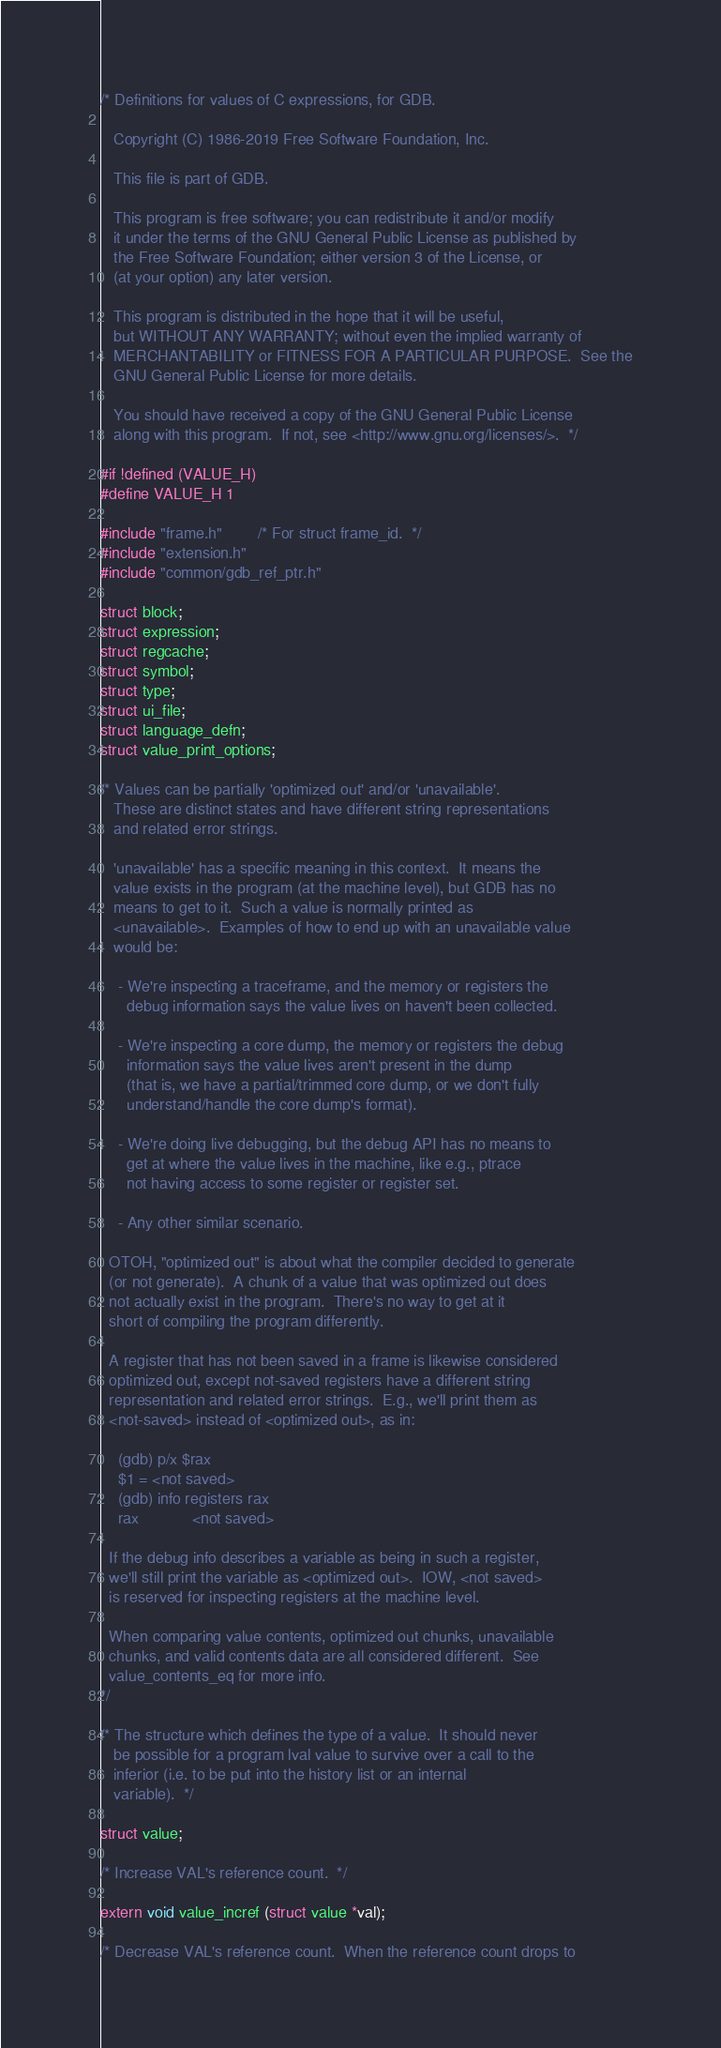Convert code to text. <code><loc_0><loc_0><loc_500><loc_500><_C_>/* Definitions for values of C expressions, for GDB.

   Copyright (C) 1986-2019 Free Software Foundation, Inc.

   This file is part of GDB.

   This program is free software; you can redistribute it and/or modify
   it under the terms of the GNU General Public License as published by
   the Free Software Foundation; either version 3 of the License, or
   (at your option) any later version.

   This program is distributed in the hope that it will be useful,
   but WITHOUT ANY WARRANTY; without even the implied warranty of
   MERCHANTABILITY or FITNESS FOR A PARTICULAR PURPOSE.  See the
   GNU General Public License for more details.

   You should have received a copy of the GNU General Public License
   along with this program.  If not, see <http://www.gnu.org/licenses/>.  */

#if !defined (VALUE_H)
#define VALUE_H 1

#include "frame.h"		/* For struct frame_id.  */
#include "extension.h"
#include "common/gdb_ref_ptr.h"

struct block;
struct expression;
struct regcache;
struct symbol;
struct type;
struct ui_file;
struct language_defn;
struct value_print_options;

/* Values can be partially 'optimized out' and/or 'unavailable'.
   These are distinct states and have different string representations
   and related error strings.

   'unavailable' has a specific meaning in this context.  It means the
   value exists in the program (at the machine level), but GDB has no
   means to get to it.  Such a value is normally printed as
   <unavailable>.  Examples of how to end up with an unavailable value
   would be:

    - We're inspecting a traceframe, and the memory or registers the
      debug information says the value lives on haven't been collected.

    - We're inspecting a core dump, the memory or registers the debug
      information says the value lives aren't present in the dump
      (that is, we have a partial/trimmed core dump, or we don't fully
      understand/handle the core dump's format).

    - We're doing live debugging, but the debug API has no means to
      get at where the value lives in the machine, like e.g., ptrace
      not having access to some register or register set.

    - Any other similar scenario.

  OTOH, "optimized out" is about what the compiler decided to generate
  (or not generate).  A chunk of a value that was optimized out does
  not actually exist in the program.  There's no way to get at it
  short of compiling the program differently.

  A register that has not been saved in a frame is likewise considered
  optimized out, except not-saved registers have a different string
  representation and related error strings.  E.g., we'll print them as
  <not-saved> instead of <optimized out>, as in:

    (gdb) p/x $rax
    $1 = <not saved>
    (gdb) info registers rax
    rax            <not saved>

  If the debug info describes a variable as being in such a register,
  we'll still print the variable as <optimized out>.  IOW, <not saved>
  is reserved for inspecting registers at the machine level.

  When comparing value contents, optimized out chunks, unavailable
  chunks, and valid contents data are all considered different.  See
  value_contents_eq for more info.
*/

/* The structure which defines the type of a value.  It should never
   be possible for a program lval value to survive over a call to the
   inferior (i.e. to be put into the history list or an internal
   variable).  */

struct value;

/* Increase VAL's reference count.  */

extern void value_incref (struct value *val);

/* Decrease VAL's reference count.  When the reference count drops to</code> 